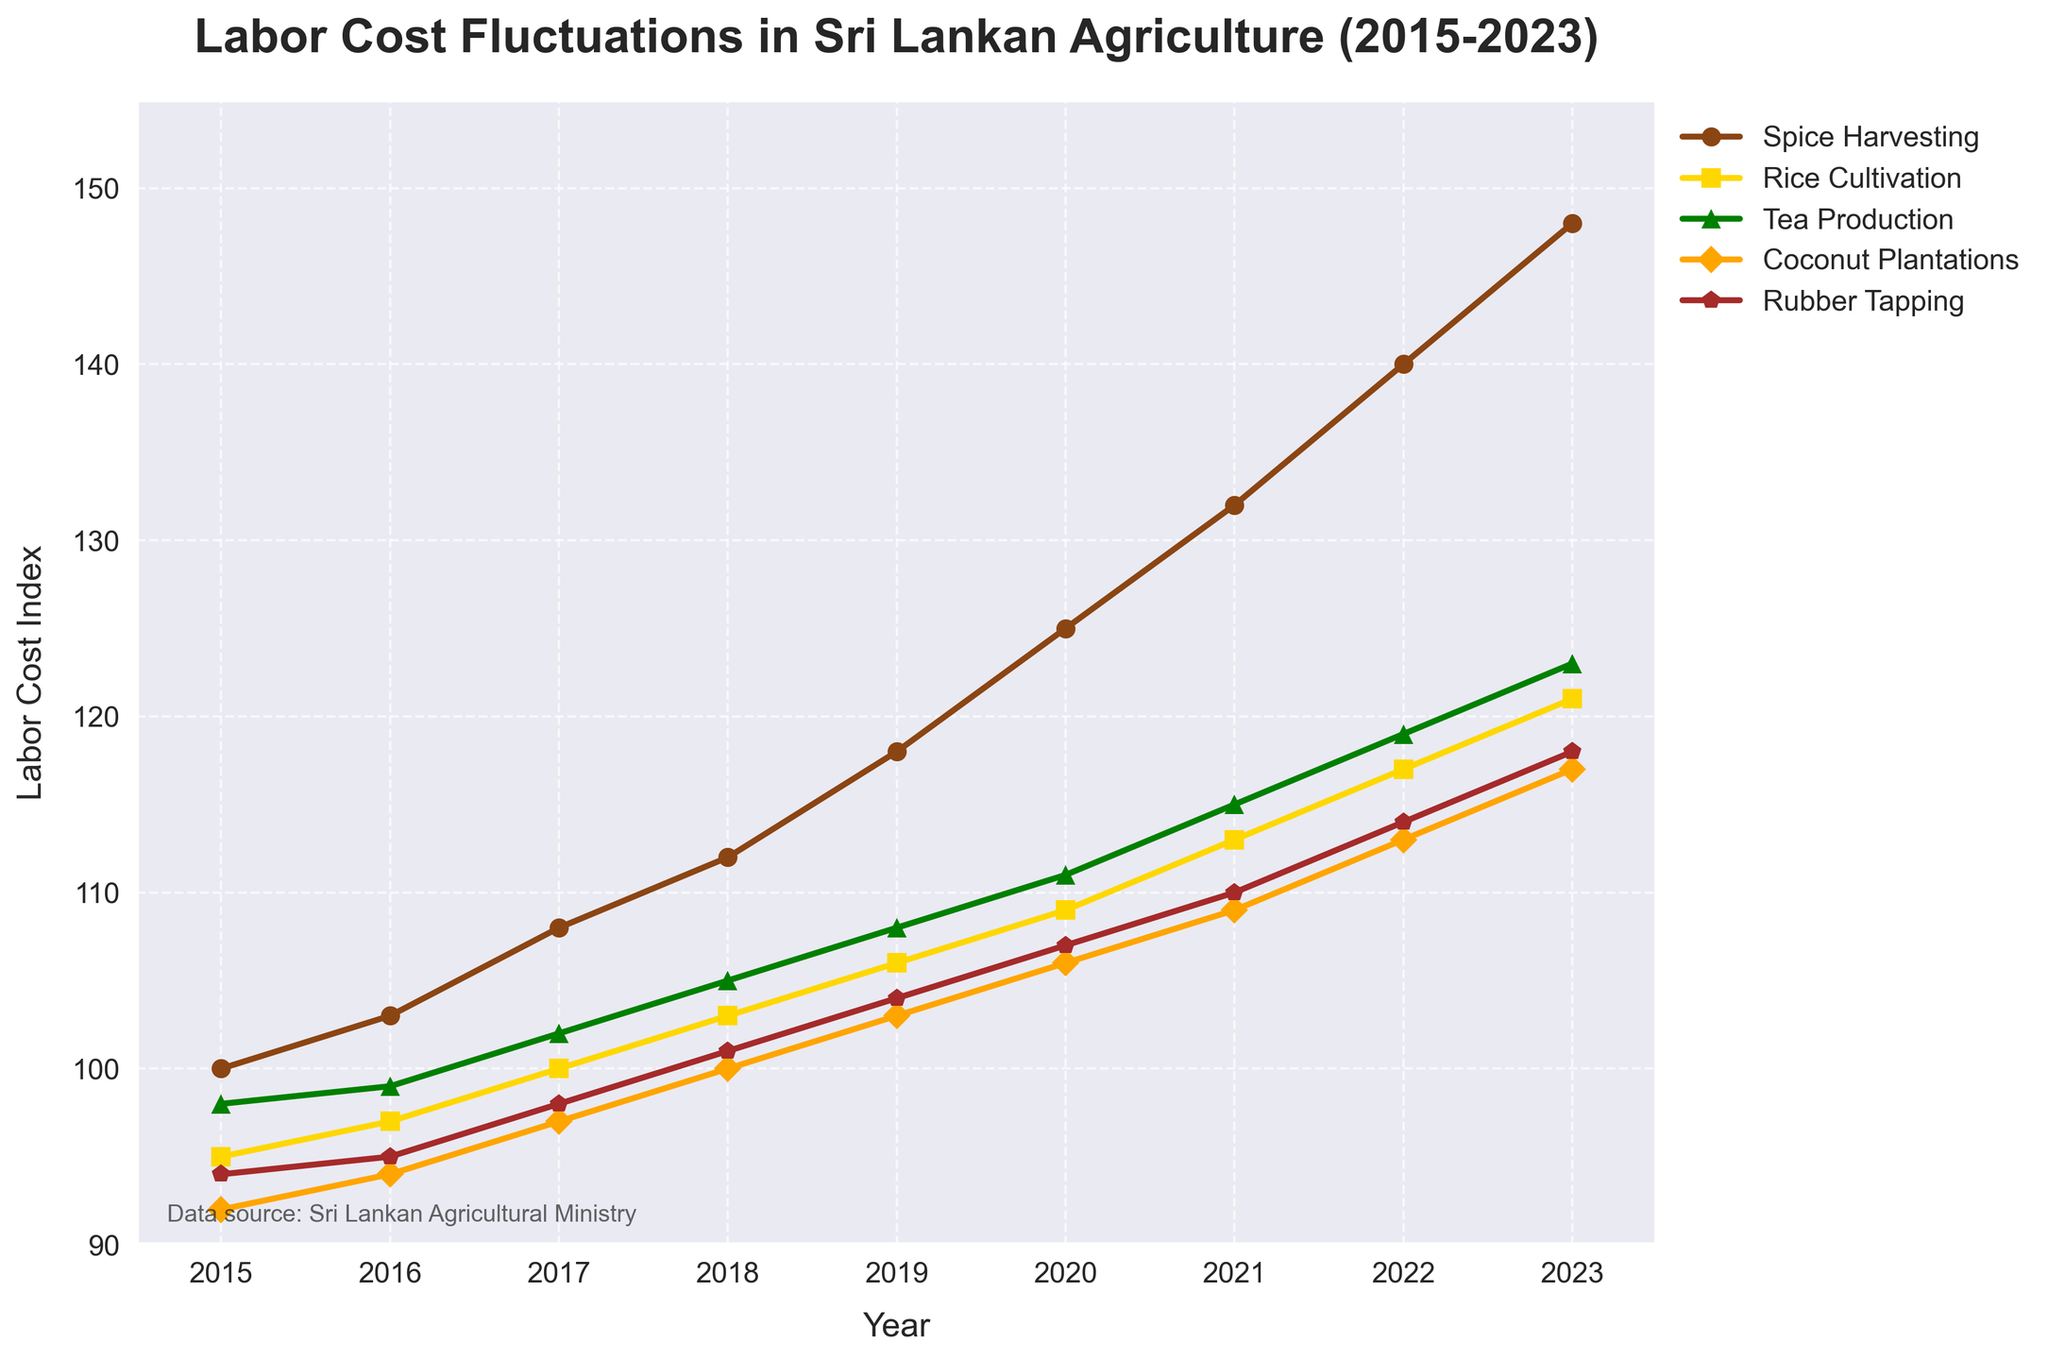What sector had the highest labor cost in 2015? Look at the year 2015 on the x-axis, and compare the values across different sectors. Spice Harvesting had the highest value at 100.
Answer: Spice Harvesting How did the labor cost for Spice Harvesting change from 2015 to 2023? Observe the values for Spice Harvesting in both 2015 (100) and 2023 (148). Subtract the earlier value from the later value: 148 - 100 = 48.
Answer: Increased by 48 Which two sectors had the closest labor costs in 2020? Compare the 2020 values for all sectors: Spice Harvesting (125), Rice Cultivation (109), Tea Production (111), Coconut Plantations (106), Rubber Tapping (107). Tea Production and Rubber Tapping differ by only 4 (111 - 107 = 4).
Answer: Tea Production and Rubber Tapping In which year did the labor cost for Rice Cultivation surpass 100? Observe the values for Rice Cultivation: 2015 (95), 2016 (97), 2017 (100), 2018 (103). It surpasses 100 in 2018.
Answer: 2018 What is the average labor cost for Coconut Plantations from 2015 to 2023? Sum the values for Coconut Plantations: 92 + 94 + 97 + 100 + 103 + 106 + 109 + 113 + 117 = 931, and divide by the number of years (9): 931 / 9 ≈ 103.44.
Answer: 103.44 Which sector showed the most consistent increase in labor costs from 2015 to 2023? Consistent increase means the pattern rises continuously. Check the trends: Every sector is rising, but Tea Production has a steady increase: 98 to 123 within 8 increments—no drastic changes compared to others.
Answer: Tea Production Between which two consecutive years did Spice Harvesting see the largest increase in labor costs? Calculate the year-to-year differences for Spice Harvesting: '16-'15 (3), '17-'16 (5), '18-'17 (4), '19-'18 (6), '20-'19 (7), '21-'20 (7), '22-'21 (8), '23-'22 (8). The largest increases are from 2021-2022 and 2022-2023, both with an 8-point rise.
Answer: 2021-2022 and 2022-2023 